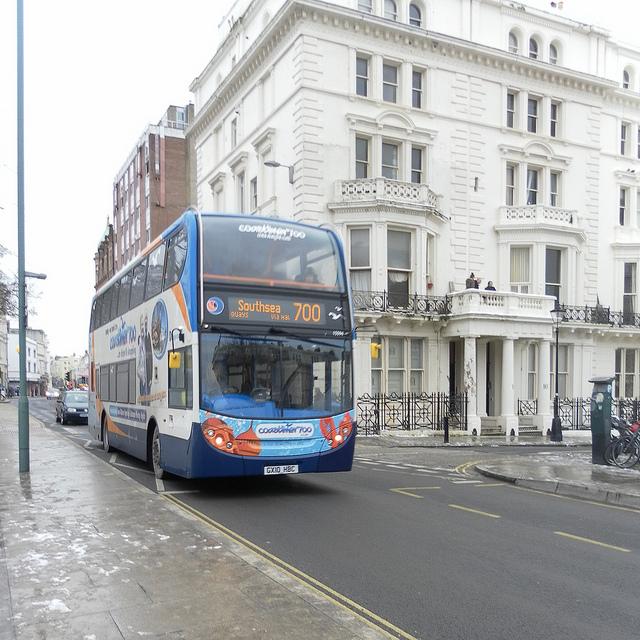Is that a car or bus?
Write a very short answer. Bus. What three digit number is on the right of the bus's electronic sign?
Answer briefly. 700. Is a bus shelter visible?
Short answer required. No. Where is this?
Answer briefly. London. 